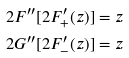Convert formula to latex. <formula><loc_0><loc_0><loc_500><loc_500>2 F ^ { \prime \prime } [ 2 F ^ { \prime } _ { + } ( z ) ] & = z \\ 2 G ^ { \prime \prime } [ 2 F ^ { \prime } _ { - } ( z ) ] & = z</formula> 